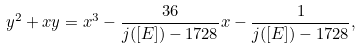Convert formula to latex. <formula><loc_0><loc_0><loc_500><loc_500>y ^ { 2 } + x y = x ^ { 3 } - \frac { 3 6 } { j ( [ E ] ) - 1 7 2 8 } x - \frac { 1 } { j ( [ E ] ) - 1 7 2 8 } ,</formula> 